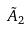<formula> <loc_0><loc_0><loc_500><loc_500>\tilde { A } _ { 2 }</formula> 